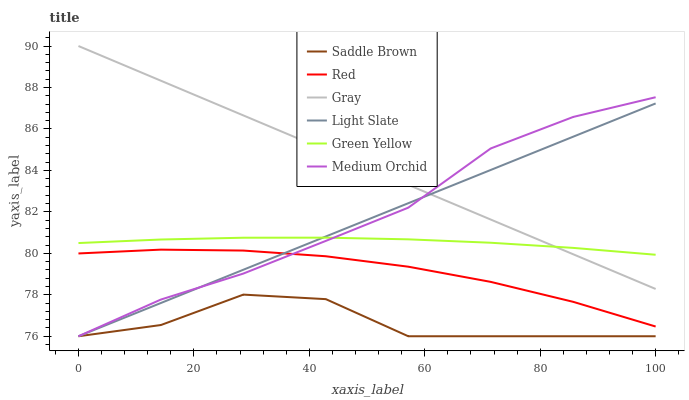Does Saddle Brown have the minimum area under the curve?
Answer yes or no. Yes. Does Gray have the maximum area under the curve?
Answer yes or no. Yes. Does Light Slate have the minimum area under the curve?
Answer yes or no. No. Does Light Slate have the maximum area under the curve?
Answer yes or no. No. Is Light Slate the smoothest?
Answer yes or no. Yes. Is Saddle Brown the roughest?
Answer yes or no. Yes. Is Medium Orchid the smoothest?
Answer yes or no. No. Is Medium Orchid the roughest?
Answer yes or no. No. Does Light Slate have the lowest value?
Answer yes or no. Yes. Does Green Yellow have the lowest value?
Answer yes or no. No. Does Gray have the highest value?
Answer yes or no. Yes. Does Light Slate have the highest value?
Answer yes or no. No. Is Red less than Gray?
Answer yes or no. Yes. Is Green Yellow greater than Saddle Brown?
Answer yes or no. Yes. Does Medium Orchid intersect Green Yellow?
Answer yes or no. Yes. Is Medium Orchid less than Green Yellow?
Answer yes or no. No. Is Medium Orchid greater than Green Yellow?
Answer yes or no. No. Does Red intersect Gray?
Answer yes or no. No. 